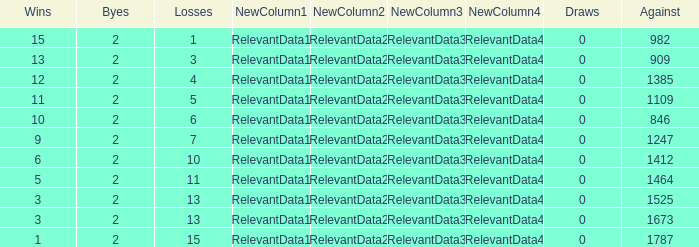What is the highest number listed under against when there were less than 3 wins and less than 15 losses? None. 